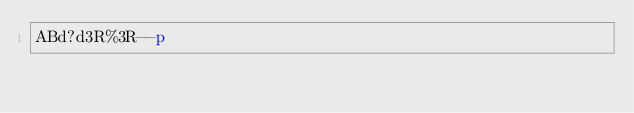<code> <loc_0><loc_0><loc_500><loc_500><_dc_>ABd?d3R%3R--p</code> 